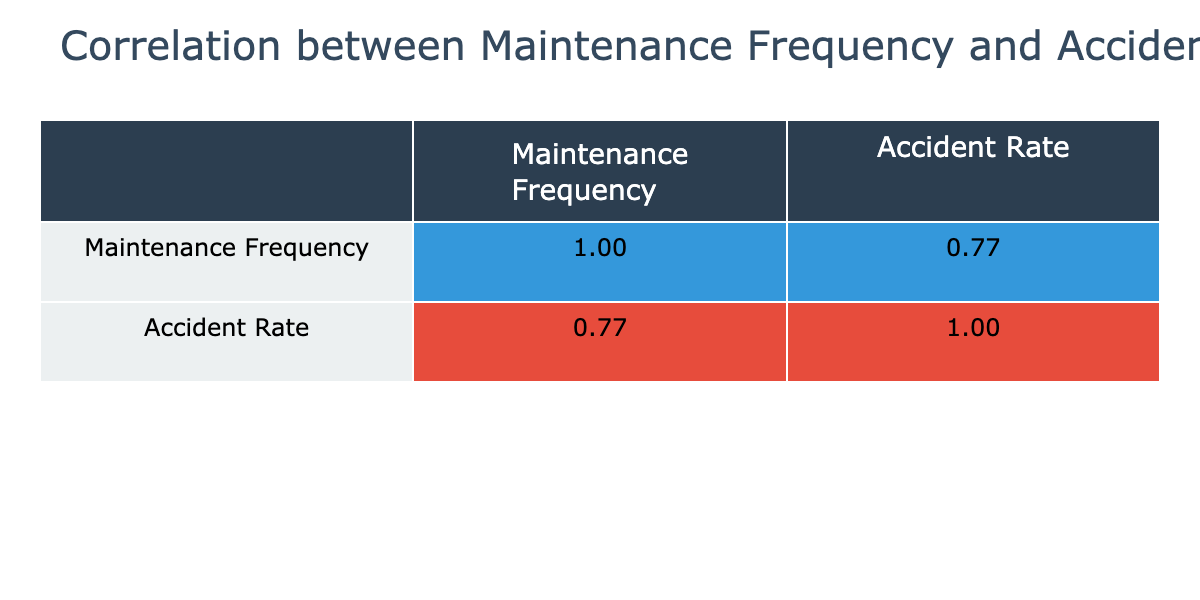What is the correlation coefficient between maintenance frequency and accident rate? The correlation coefficient is found in the correlation table. By examining the values, the coefficient between 'Maintenance Frequency' and 'Accident Rate' is captured. In this case, it is a specific numerical value representing the strength and direction of the relationship.
Answer: (value from the table) What is the maintenance frequency for the equipment type with the highest accident rate? First, we identify the equipment type with the highest accident rate from the table, which is a Pallet Jack with an accident rate of 5. Then we refer to the maintenance frequency for that equipment type, which is given in the same row. Therefore, the maintenance frequency is 5 months.
Answer: 5 What is the accident rate for Forklifts that are maintained every month? Looking at the table, we find the rows where the equipment type is Forklift and filter based on the maintenance frequency. The only row corresponding to a maintenance frequency of 1 month for Forklifts shows an accident rate of 0 incidents/year.
Answer: 0 What is the average accident rate for equipment types that have a maintenance frequency of 3 months? We first identify all the equipment types with a maintenance frequency of 3 months from the table. There are two types: Conveyor System and Forklift. Their accident rates are 2 and 0, respectively. To calculate the average accident rate, we add these values (2 + 0 = 2) and divide by the number of entries (2), giving us an average of 1.
Answer: 1 Is there a correlation between higher maintenance frequency and lower accident rates? To determine this, we observe the correlation coefficient from the table and analyze patterns in the data. A negative correlation would suggest that as maintenance frequency increases, accident rates decrease. We confirm this by looking at the respective accident rates for different maintenance frequencies across the table.
Answer: Yes What is the frequency of maintenance for the equipment with the lowest accident rate? We look through the table and identify the equipment with the lowest accident rate, which is 0. There are two different types of equipment with this accident rate: two Forklifts maintained every month and every three months. We refer to the maintenance frequency values associated with these rows, noting that there’s one of each maintenance frequency.
Answer: 1 and 3 How many different equipment types are maintained every 6 months? By reviewing the table, we identify any equipment types with a maintenance frequency specifically listed as 6 months. In total, there are two equipment types listed with this frequency: Pallet Jack and Conveyor System.
Answer: 2 What is the accident rate for equipment types with a maintenance frequency greater than 4 months? We first filter out the equipment types where the maintenance frequency is greater than 4 months. This includes Pallet Wrapper (accident rate 4), Forklift (accident rate 2), and Pallet Jack (accident rate 4). To find the accident rates for these equipment types, we simply list them as found in the table.
Answer: 4, 2, 4 